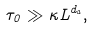Convert formula to latex. <formula><loc_0><loc_0><loc_500><loc_500>\tau _ { 0 } \gg \kappa L ^ { d _ { a } } ,</formula> 